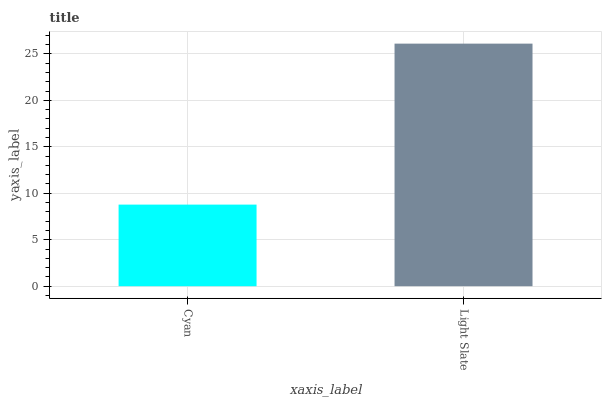Is Cyan the minimum?
Answer yes or no. Yes. Is Light Slate the maximum?
Answer yes or no. Yes. Is Light Slate the minimum?
Answer yes or no. No. Is Light Slate greater than Cyan?
Answer yes or no. Yes. Is Cyan less than Light Slate?
Answer yes or no. Yes. Is Cyan greater than Light Slate?
Answer yes or no. No. Is Light Slate less than Cyan?
Answer yes or no. No. Is Light Slate the high median?
Answer yes or no. Yes. Is Cyan the low median?
Answer yes or no. Yes. Is Cyan the high median?
Answer yes or no. No. Is Light Slate the low median?
Answer yes or no. No. 